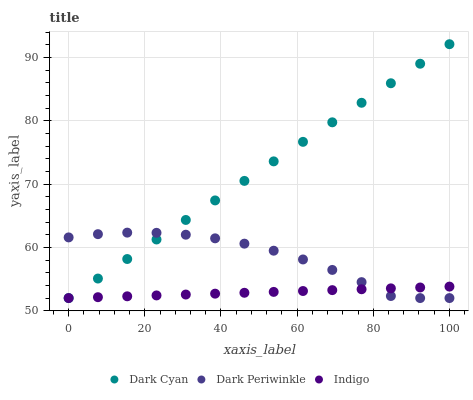Does Indigo have the minimum area under the curve?
Answer yes or no. Yes. Does Dark Cyan have the maximum area under the curve?
Answer yes or no. Yes. Does Dark Periwinkle have the minimum area under the curve?
Answer yes or no. No. Does Dark Periwinkle have the maximum area under the curve?
Answer yes or no. No. Is Indigo the smoothest?
Answer yes or no. Yes. Is Dark Periwinkle the roughest?
Answer yes or no. Yes. Is Dark Periwinkle the smoothest?
Answer yes or no. No. Is Indigo the roughest?
Answer yes or no. No. Does Dark Cyan have the lowest value?
Answer yes or no. Yes. Does Dark Cyan have the highest value?
Answer yes or no. Yes. Does Dark Periwinkle have the highest value?
Answer yes or no. No. Does Dark Cyan intersect Indigo?
Answer yes or no. Yes. Is Dark Cyan less than Indigo?
Answer yes or no. No. Is Dark Cyan greater than Indigo?
Answer yes or no. No. 